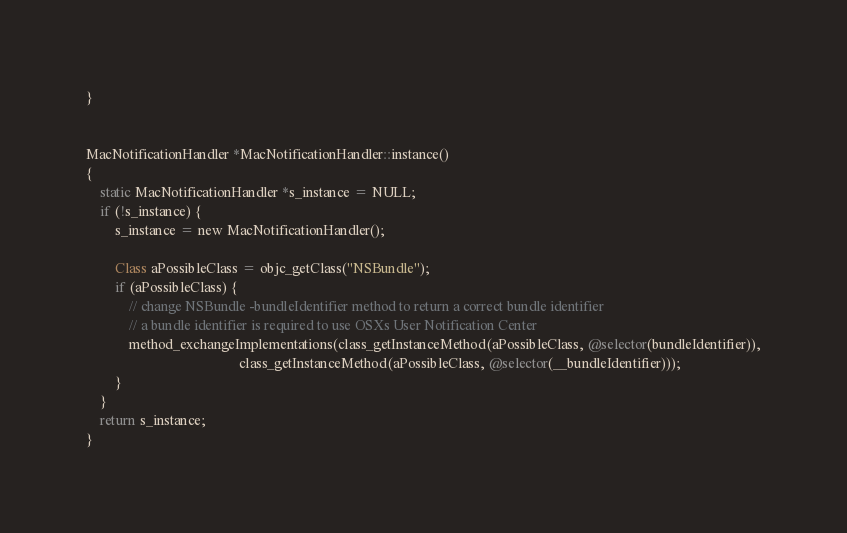<code> <loc_0><loc_0><loc_500><loc_500><_ObjectiveC_>}


MacNotificationHandler *MacNotificationHandler::instance()
{
    static MacNotificationHandler *s_instance = NULL;
    if (!s_instance) {
        s_instance = new MacNotificationHandler();
        
        Class aPossibleClass = objc_getClass("NSBundle");
        if (aPossibleClass) {
            // change NSBundle -bundleIdentifier method to return a correct bundle identifier
            // a bundle identifier is required to use OSXs User Notification Center
            method_exchangeImplementations(class_getInstanceMethod(aPossibleClass, @selector(bundleIdentifier)),
                                           class_getInstanceMethod(aPossibleClass, @selector(__bundleIdentifier)));
        }
    }
    return s_instance;
}
</code> 